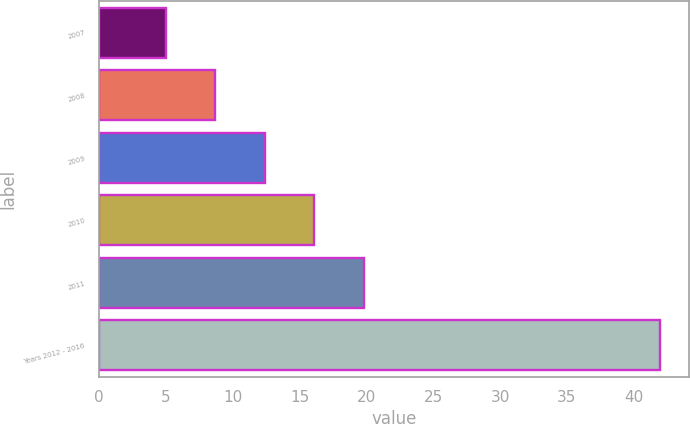<chart> <loc_0><loc_0><loc_500><loc_500><bar_chart><fcel>2007<fcel>2008<fcel>2009<fcel>2010<fcel>2011<fcel>Years 2012 - 2016<nl><fcel>5<fcel>8.7<fcel>12.4<fcel>16.1<fcel>19.8<fcel>42<nl></chart> 